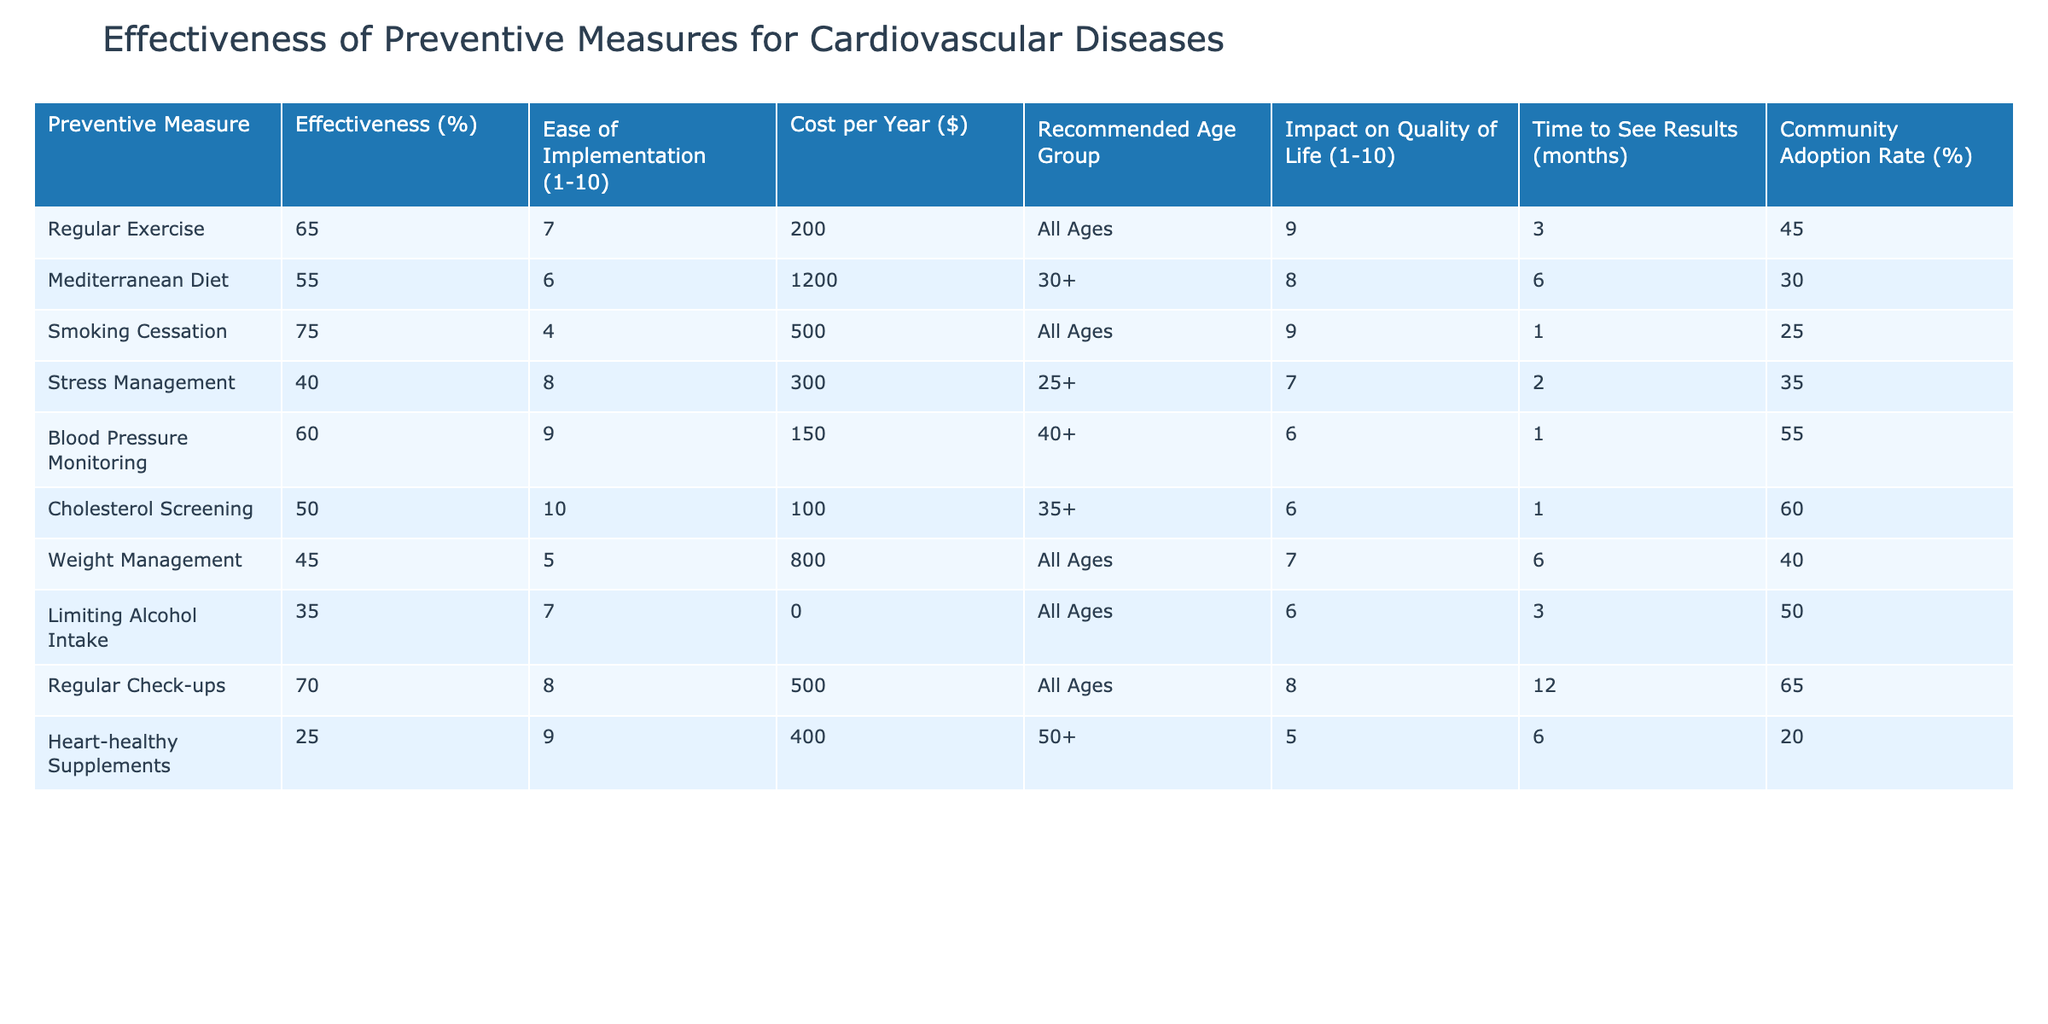What is the effectiveness percentage of Smoking Cessation? The effectiveness of Smoking Cessation is provided directly in the table under the "Effectiveness (%)" column. It shows a value of 75%.
Answer: 75% Which preventive measure has the lowest impact on quality of life? In the "Impact on Quality of Life (1-10)" column, the values range from 5 to 9. Heart-healthy Supplements has the lowest score of 5.
Answer: Heart-healthy Supplements What is the average cost per year of the preventive measures? To calculate the average cost, sum all the values in the "Cost per Year ($)" column: 200 + 1200 + 500 + 300 + 150 + 100 + 800 + 0 + 500 + 400 = 3150. There are 10 measures, so the average is 3150 / 10 = 315.
Answer: 315 Is the Community Adoption Rate for Regular Exercise higher than that for Weight Management? The Community Adoption Rate for Regular Exercise is 45%, while for Weight Management it is 40%. Therefore, Regular Exercise has a higher rate.
Answer: Yes What is the time to see results for the Mediterranean Diet compared to Smoking Cessation? The "Time to See Results (months)" for the Mediterranean Diet is 6 months, while for Smoking Cessation it is 1 month. Comparing these values, Smoking Cessation has a shorter time.
Answer: Smoking Cessation If we consider the top three preventive measures based on effectiveness, what is their average effectiveness? The effectiveness values for the top three measures (Smoking Cessation, Regular Check-ups, and Regular Exercise) are 75%, 70%, and 65%, respectively. The sum is 75 + 70 + 65 = 210, and the average is 210 / 3 = 70.
Answer: 70 Which preventive measure has the highest ease of implementation? Looking under the "Ease of Implementation (1-10)" column, Cholesterol Screening has the highest score of 10.
Answer: Cholesterol Screening Is there a preventive measure that provides both a high effectiveness and ease of implementation? High effectiveness is defined as above 60%, which applies to Smoking Cessation, Regular Check-ups, and Regular Exercise. The highest ease of implementation in this group is 8 for both Regular Check-ups and Regular Exercise. Thus, both measures fulfill the criteria.
Answer: Yes How much more does the Mediterranean Diet cost annually compared to Limiting Alcohol Intake? The cost of the Mediterranean Diet is $1200, while Limiting Alcohol Intake costs $0. The difference is 1200 - 0 = 1200.
Answer: 1200 What percentage of the recommended age group for Weight Management is "All Ages"? The table shows that the recommended age group for Weight Management is "All Ages." Therefore, 100% of this measure is for all ages.
Answer: 100% 